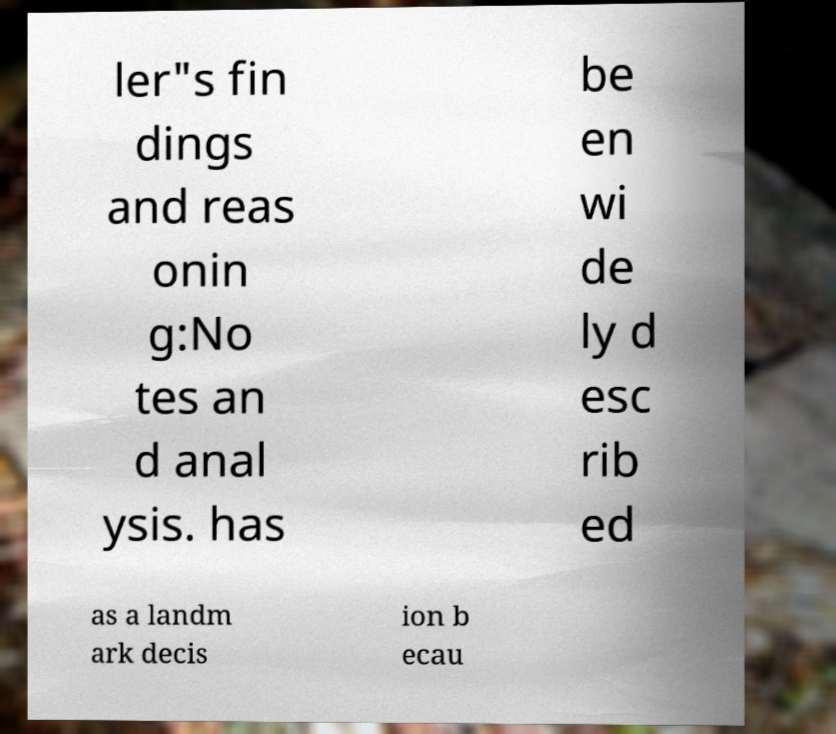Could you extract and type out the text from this image? ler"s fin dings and reas onin g:No tes an d anal ysis. has be en wi de ly d esc rib ed as a landm ark decis ion b ecau 